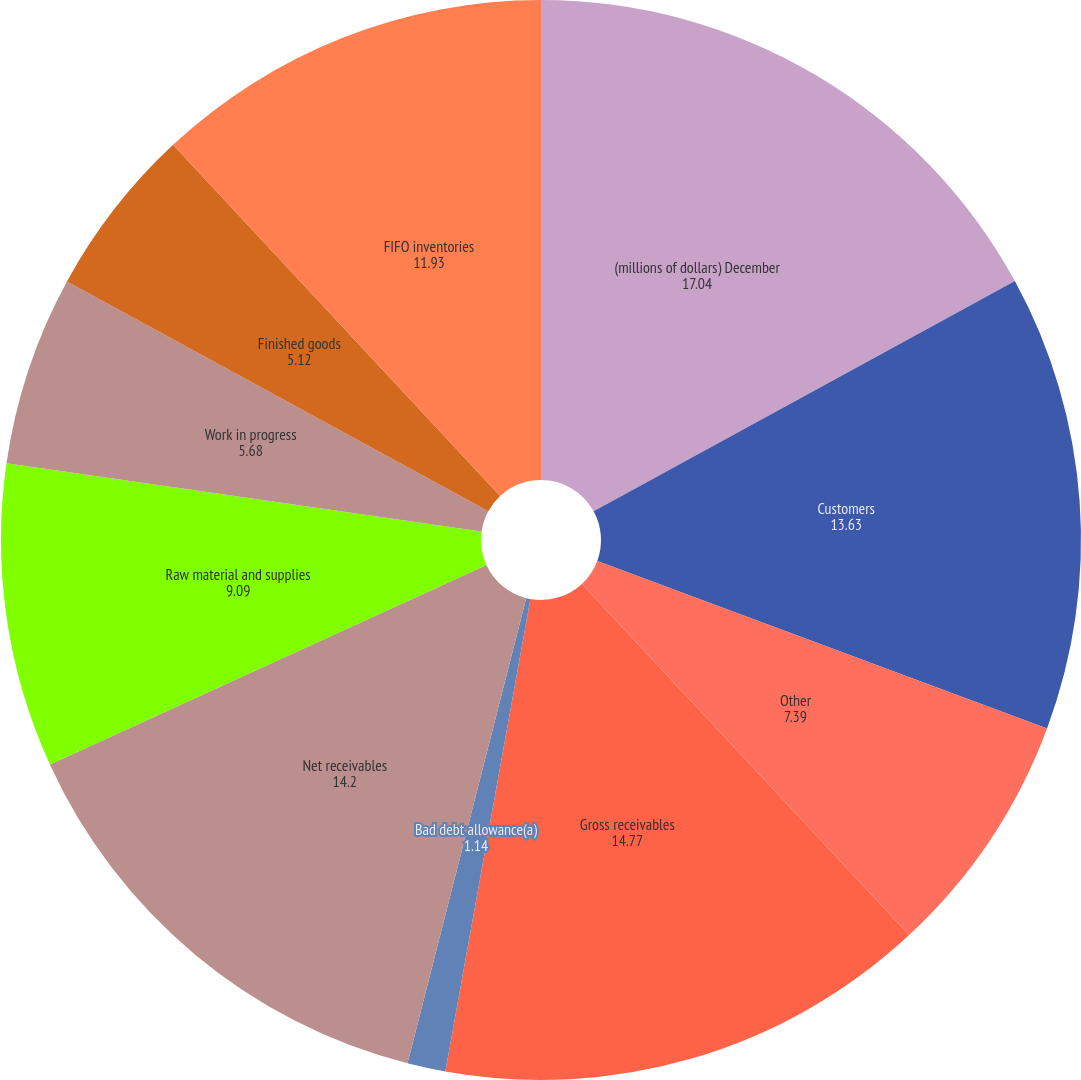<chart> <loc_0><loc_0><loc_500><loc_500><pie_chart><fcel>(millions of dollars) December<fcel>Customers<fcel>Other<fcel>Gross receivables<fcel>Bad debt allowance(a)<fcel>Net receivables<fcel>Raw material and supplies<fcel>Work in progress<fcel>Finished goods<fcel>FIFO inventories<nl><fcel>17.04%<fcel>13.63%<fcel>7.39%<fcel>14.77%<fcel>1.14%<fcel>14.2%<fcel>9.09%<fcel>5.68%<fcel>5.12%<fcel>11.93%<nl></chart> 